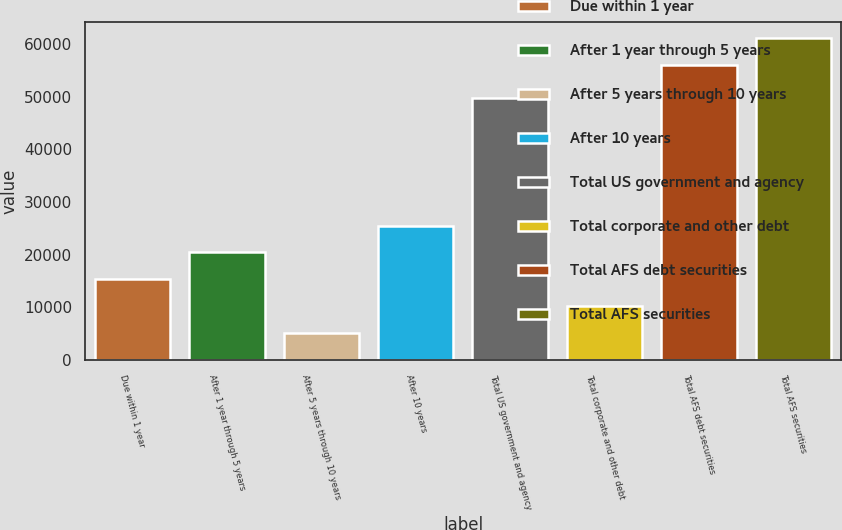Convert chart to OTSL. <chart><loc_0><loc_0><loc_500><loc_500><bar_chart><fcel>Due within 1 year<fcel>After 1 year through 5 years<fcel>After 5 years through 10 years<fcel>After 10 years<fcel>Total US government and agency<fcel>Total corporate and other debt<fcel>Total AFS debt securities<fcel>Total AFS securities<nl><fcel>15331.6<fcel>20424.4<fcel>5146<fcel>25517.2<fcel>49645<fcel>10238.8<fcel>56059<fcel>61151.8<nl></chart> 